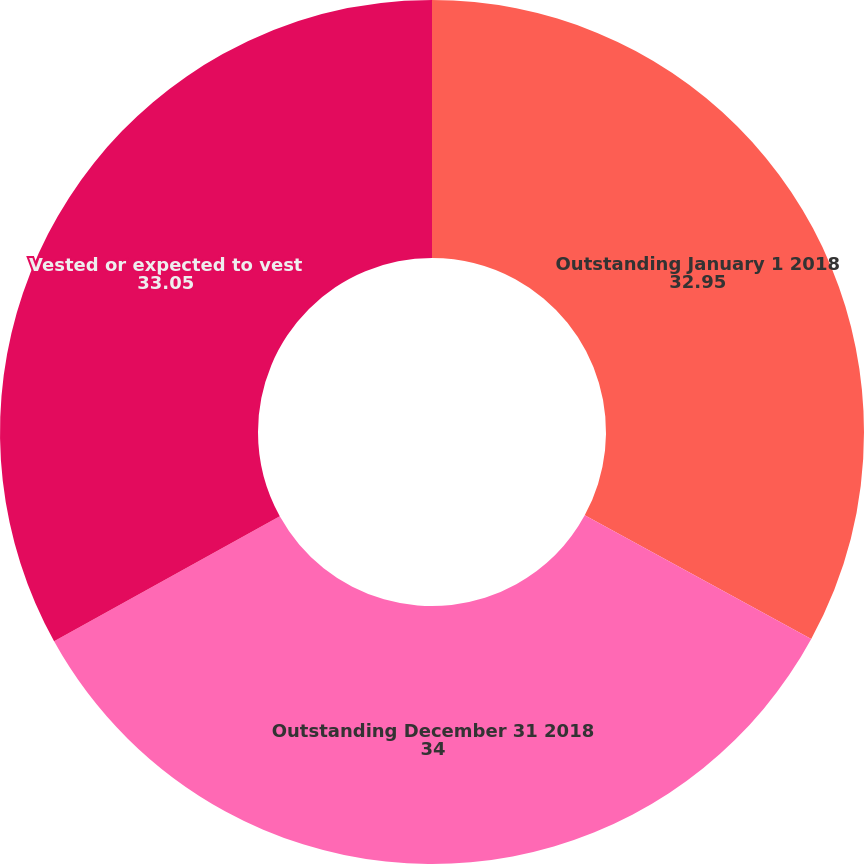Convert chart to OTSL. <chart><loc_0><loc_0><loc_500><loc_500><pie_chart><fcel>Outstanding January 1 2018<fcel>Outstanding December 31 2018<fcel>Vested or expected to vest<nl><fcel>32.95%<fcel>34.0%<fcel>33.05%<nl></chart> 